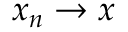<formula> <loc_0><loc_0><loc_500><loc_500>x _ { n } \to x</formula> 